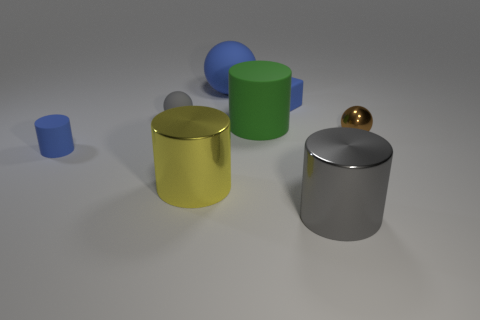What number of tiny things are metal spheres or green rubber spheres?
Give a very brief answer. 1. What number of other objects are the same color as the small matte cube?
Provide a short and direct response. 2. How many small matte blocks are behind the small ball that is to the left of the large metal thing that is on the left side of the gray shiny thing?
Make the answer very short. 1. There is a blue block on the right side of the yellow thing; does it have the same size as the green object?
Keep it short and to the point. No. Are there fewer large cylinders that are behind the tiny metallic object than big things to the right of the large yellow thing?
Offer a very short reply. Yes. Is the color of the cube the same as the big matte sphere?
Your response must be concise. Yes. Is the number of small shiny objects right of the metallic ball less than the number of large green rubber cubes?
Give a very brief answer. No. What is the material of the small thing that is the same color as the block?
Offer a very short reply. Rubber. Are the small brown ball and the large yellow thing made of the same material?
Keep it short and to the point. Yes. What number of cylinders have the same material as the brown thing?
Offer a terse response. 2. 